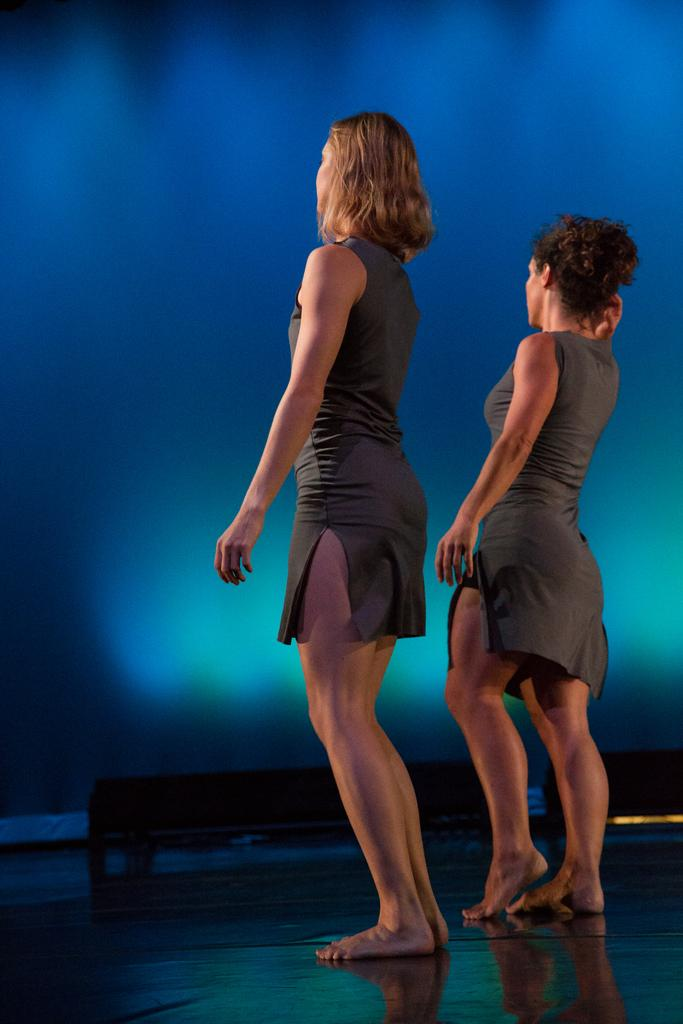How many people are in the image? There are two women in the image. What are the women doing in the image? The women are standing. What color is the background of the image? The background of the image is blue. What type of lawyer is standing next to the harbor in the image? There is no lawyer or harbor present in the image; it features two women standing against a blue background. 